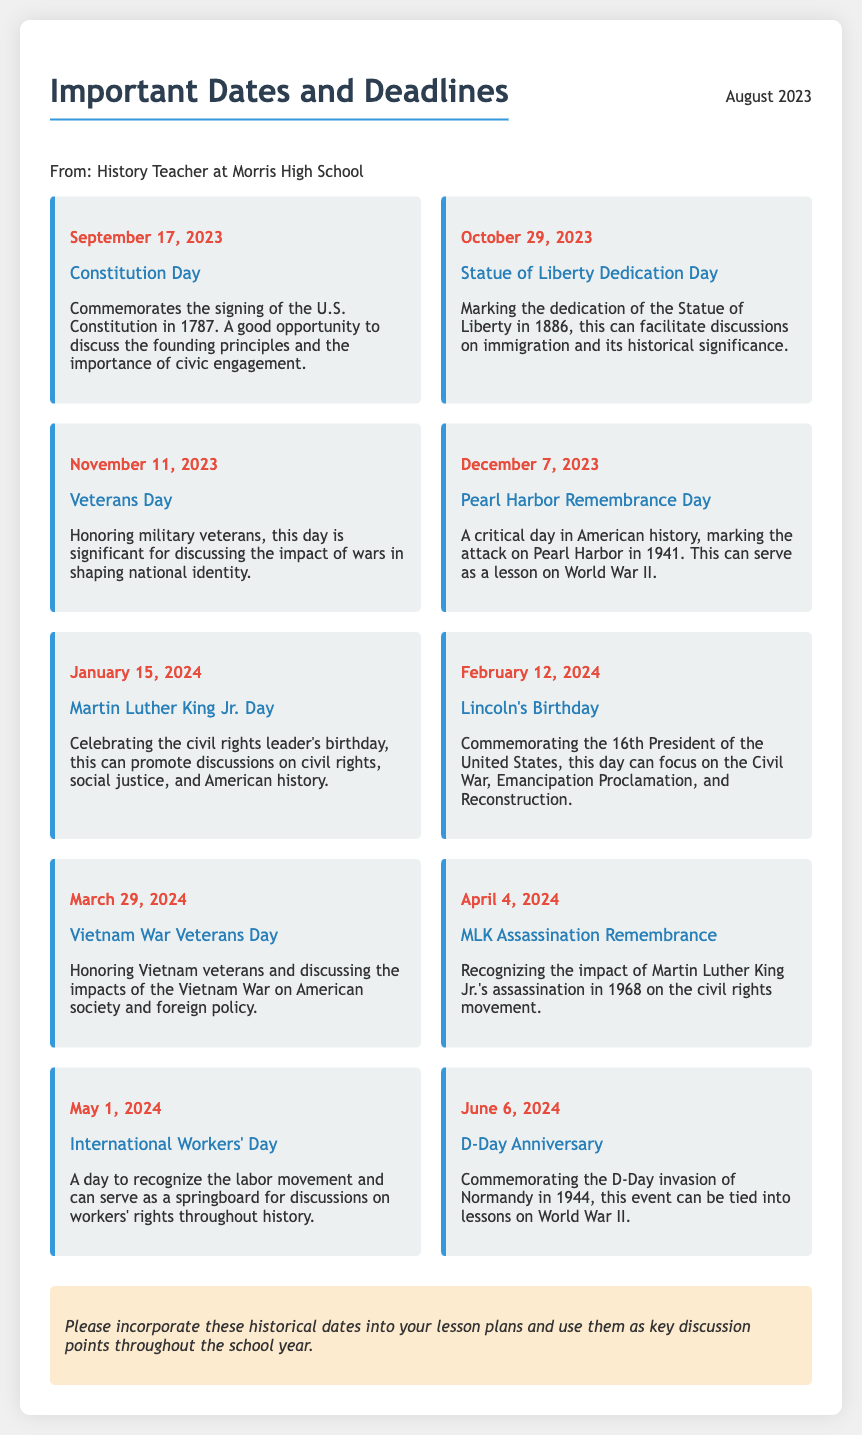What day is Constitution Day? Constitution Day is specified in the document as being on September 17, 2023.
Answer: September 17, 2023 What significant event is commemorated on November 11? The document states that November 11 is Veterans Day, which honors military veterans.
Answer: Veterans Day What year did the attack on Pearl Harbor occur? The memo indicates that Pearl Harbor was attacked in 1941, which is specified in the description of the day.
Answer: 1941 Which holiday is celebrated on January 15? According to the memo, January 15 is Martin Luther King Jr. Day, celebrating the civil rights leader's birthday.
Answer: Martin Luther King Jr. Day What does April 4th commemorate? The document explains that April 4, 2024, recognizes the impact of Martin Luther King Jr.'s assassination in 1968.
Answer: MLK Assassination Remembrance What is the theme of International Workers' Day? The memo indicates that May 1, 2024, is International Workers' Day, which recognizes the labor movement.
Answer: Labor movement How many historical dates are listed in the memo? By counting the dates present in the memo, there are 10 significant dates provided.
Answer: 10 What can teachers incorporate into lesson plans according to the memo? The note at the end of the memo encourages integrating historical dates as discussion points throughout the school year.
Answer: Historical dates What is the document's purpose? The document clearly aims to outline important dates and deadlines for the upcoming school year relevant to the history curriculum.
Answer: Important dates and deadlines 